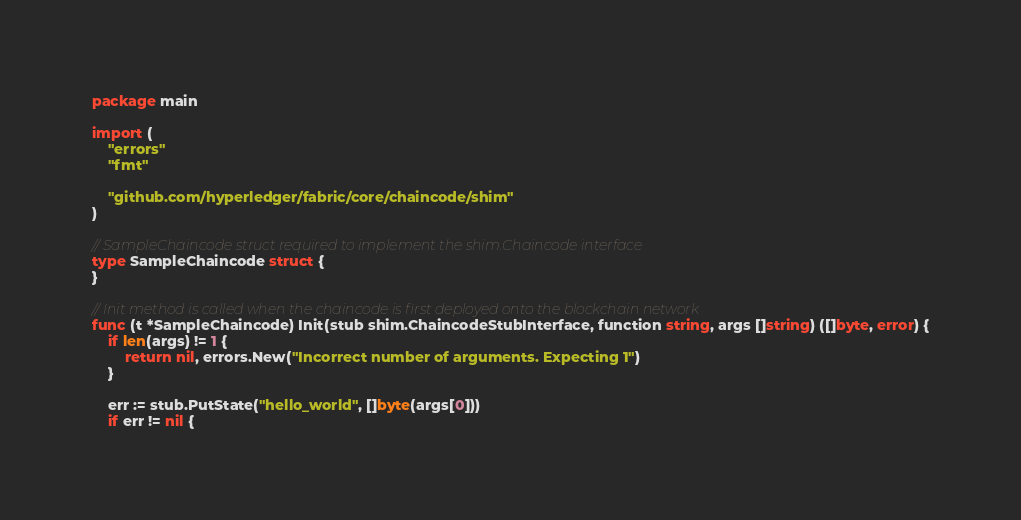Convert code to text. <code><loc_0><loc_0><loc_500><loc_500><_Go_>package main

import (
	"errors"
	"fmt"

	"github.com/hyperledger/fabric/core/chaincode/shim"
)

// SampleChaincode struct required to implement the shim.Chaincode interface
type SampleChaincode struct {
}

// Init method is called when the chaincode is first deployed onto the blockchain network
func (t *SampleChaincode) Init(stub shim.ChaincodeStubInterface, function string, args []string) ([]byte, error) {
	if len(args) != 1 {
		return nil, errors.New("Incorrect number of arguments. Expecting 1")
	}

	err := stub.PutState("hello_world", []byte(args[0]))
	if err != nil {</code> 